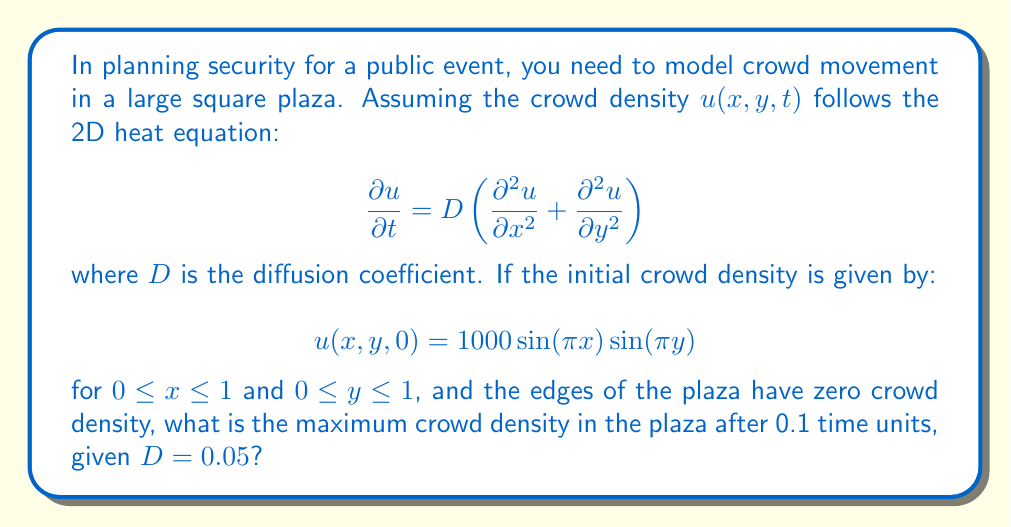Give your solution to this math problem. To solve this problem, we'll follow these steps:

1) The general solution to the 2D heat equation with the given boundary conditions is:

   $$u(x,y,t) = \sum_{m=1}^{\infty}\sum_{n=1}^{\infty}A_{mn}\sin(m\pi x)\sin(n\pi y)e^{-D(m^2+n^2)\pi^2t}$$

2) Comparing this with our initial condition, we see that $m=n=1$ and $A_{11} = 1000$. All other $A_{mn}$ are zero.

3) Therefore, our solution simplifies to:

   $$u(x,y,t) = 1000\sin(\pi x)\sin(\pi y)e^{-2D\pi^2t}$$

4) To find the maximum density, we need to maximize this function at $t=0.1$:

   $$u(x,y,0.1) = 1000\sin(\pi x)\sin(\pi y)e^{-2(0.05)\pi^2(0.1)}$$

5) The maximum of $\sin(\pi x)\sin(\pi y)$ occurs at $x=y=0.5$ (the center of the plaza) and equals 1.

6) Therefore, the maximum density is:

   $$u_{max} = 1000 \cdot e^{-0.01\pi^2} \approx 904.84$$

7) Rounding to the nearest whole number (as we're dealing with people), the maximum crowd density is 905 people per unit area.
Answer: 905 people per unit area 